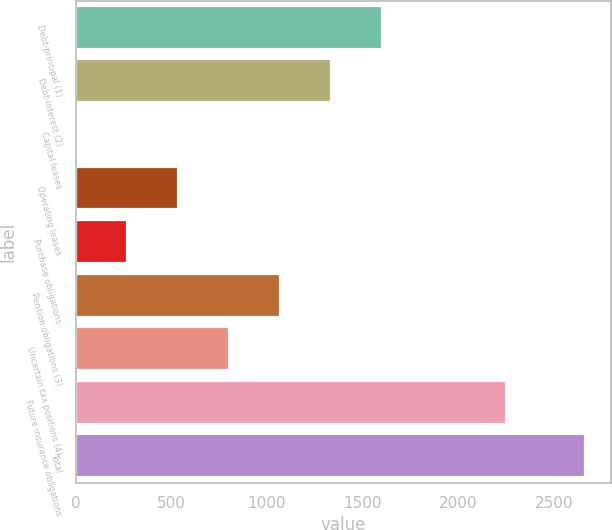<chart> <loc_0><loc_0><loc_500><loc_500><bar_chart><fcel>Debt-principal (1)<fcel>Debt-interest (2)<fcel>Capital leases<fcel>Operating leases<fcel>Purchase obligations<fcel>Pension obligations (3)<fcel>Uncertain tax positions (4)<fcel>Future insurance obligations<fcel>Total<nl><fcel>1598.5<fcel>1332.12<fcel>0.22<fcel>532.98<fcel>266.6<fcel>1065.74<fcel>799.36<fcel>2248<fcel>2664<nl></chart> 